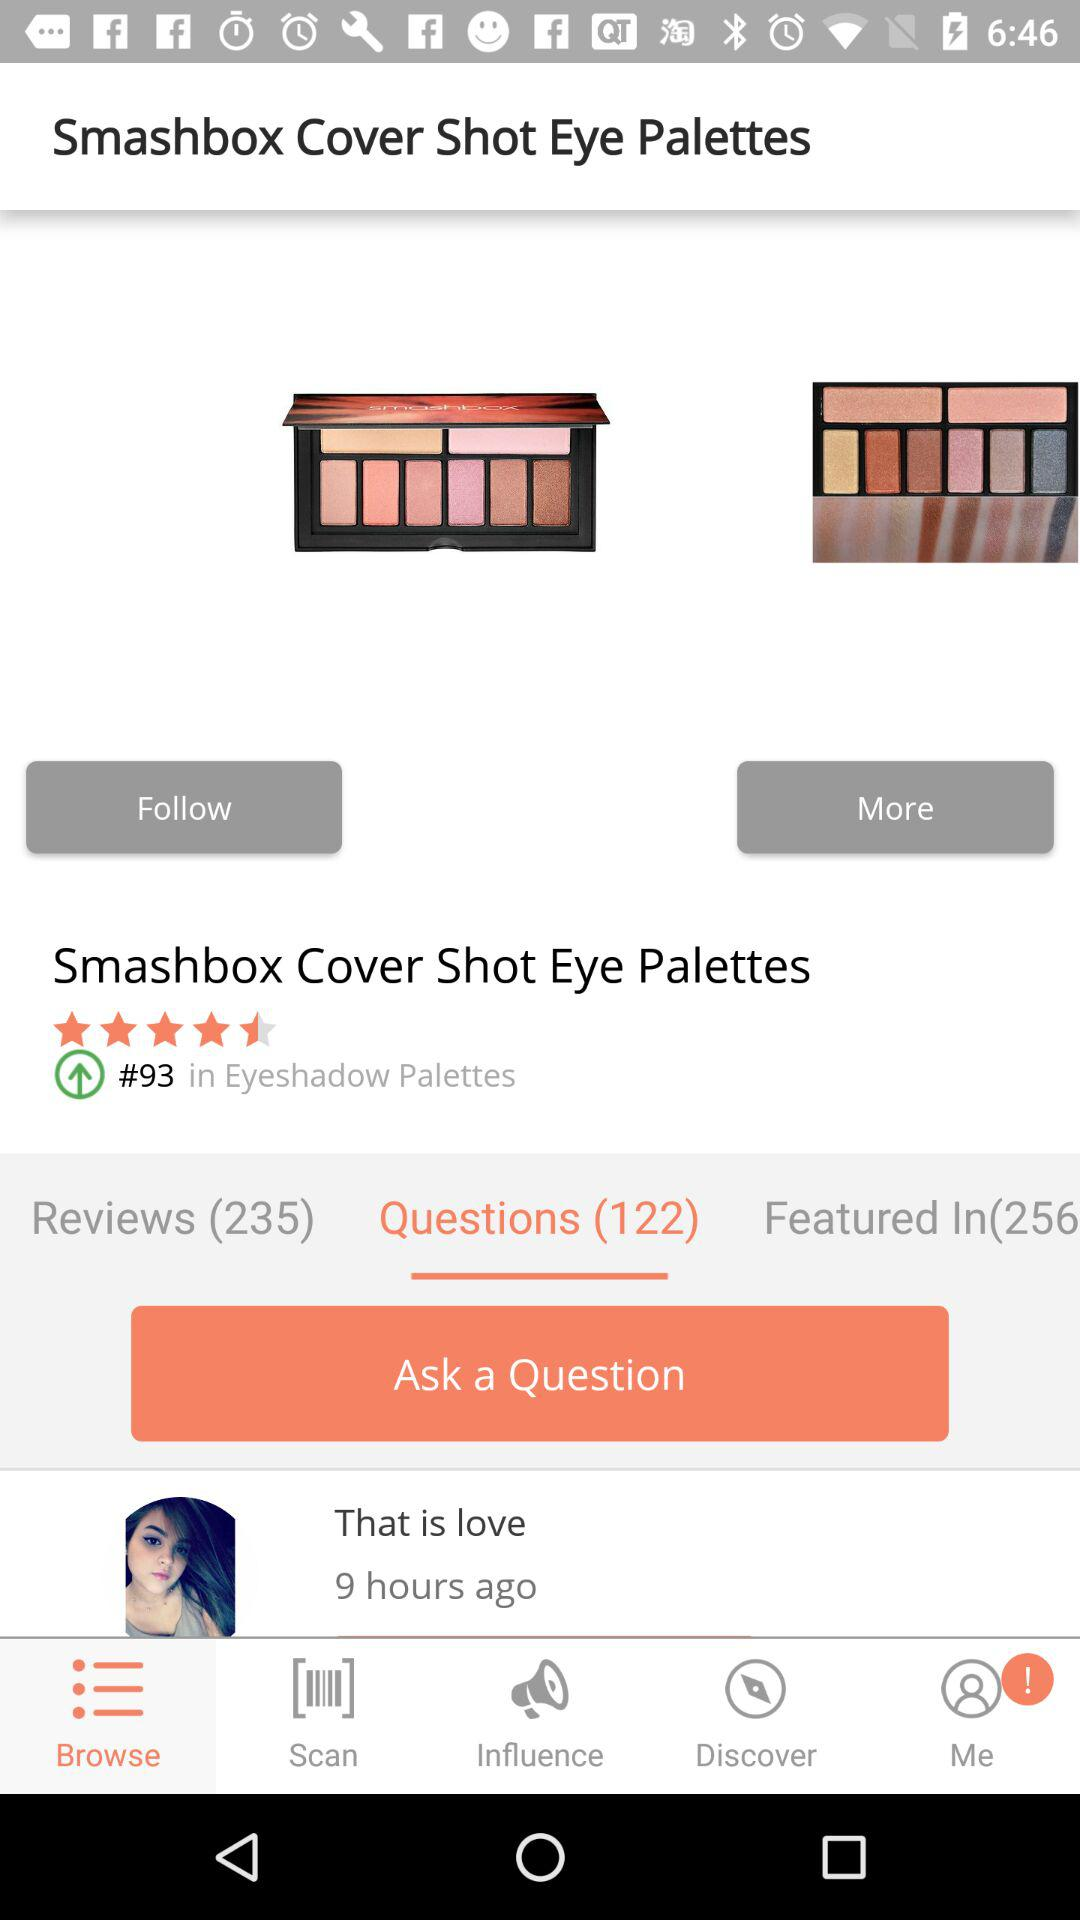How many questions are there for this product?
Answer the question using a single word or phrase. 122 